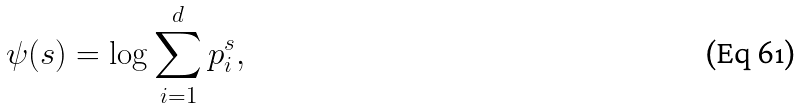Convert formula to latex. <formula><loc_0><loc_0><loc_500><loc_500>\psi ( s ) = \log \sum _ { i = 1 } ^ { d } p _ { i } ^ { s } ,</formula> 